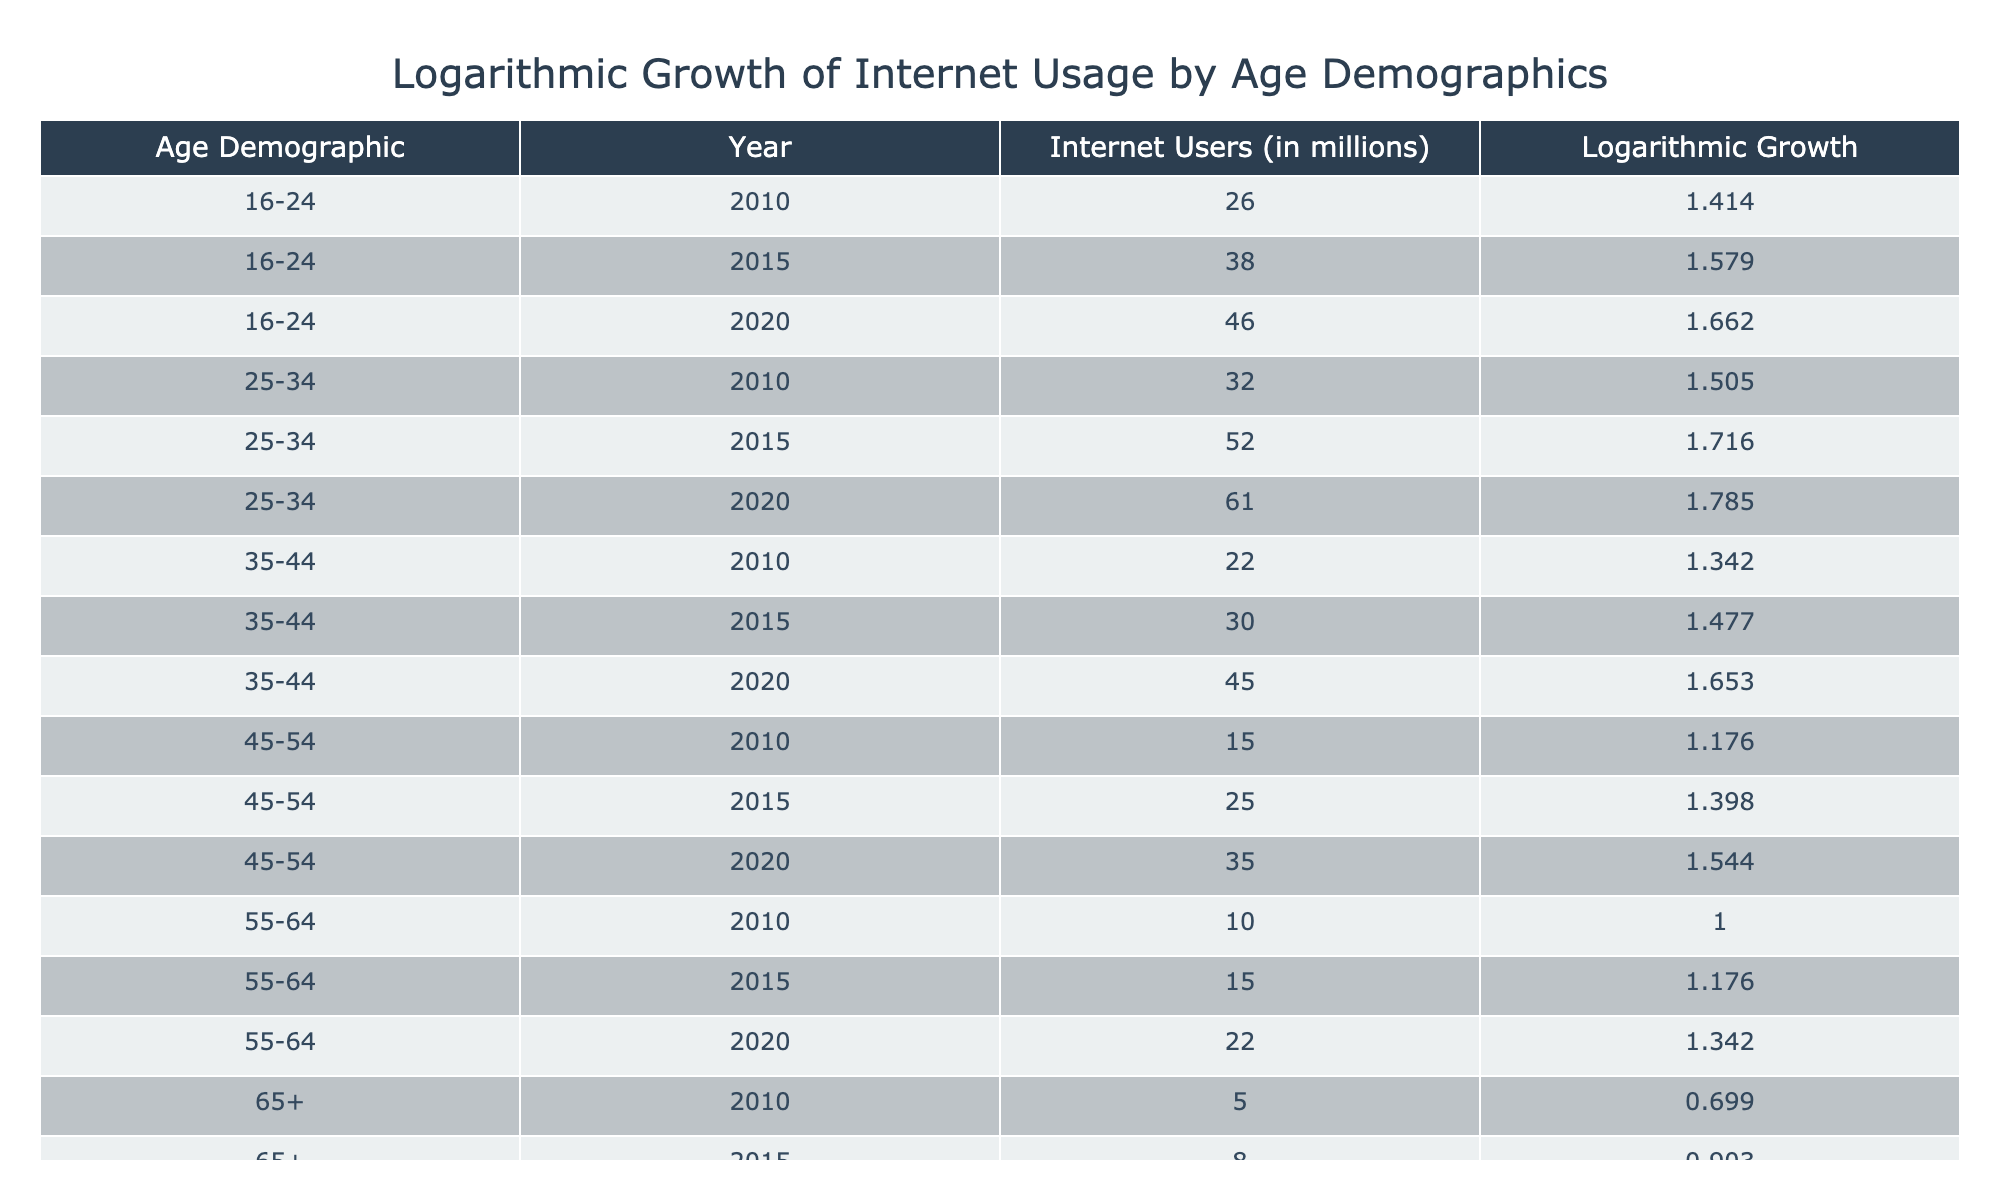What was the logarithmic growth of internet users aged 45-54 in 2015? According to the table, for the age demographic 45-54 in the year 2015, the logarithmic growth is provided directly in the 'Logarithmic Growth' column as 1.398.
Answer: 1.398 What is the total number of internet users in millions across all age demographics in 2020? To find the total number of internet users in 2020, we need to sum the values in the 'Internet Users (in millions)' column for each age demographic in that year: (46 + 61 + 45 + 35 + 22 + 13) = 222 million users.
Answer: 222 million Is the logarithmic growth of internet users aged 55-64 higher in 2020 than in 2015? By comparing the values under the 'Logarithmic Growth' column for the 55-64 age group, we find that it's 1.342 in 2020 and 1.176 in 2015. Since 1.342 is greater than 1.176, the statement is true.
Answer: Yes What was the percentage increase in internet users aged 16-24 from 2010 to 2020? For the demographic 16-24, the number of users increased from 26 million in 2010 to 46 million in 2020. The percentage increase is calculated as ((46 - 26) / 26) * 100 = 76.92%.
Answer: 76.92% Which age demographic had the lowest amount of internet users in 2010, and how many users were there? In 2010, the age group 65+ had the lowest number of internet users, which was 5 million.
Answer: 65+; 5 million 